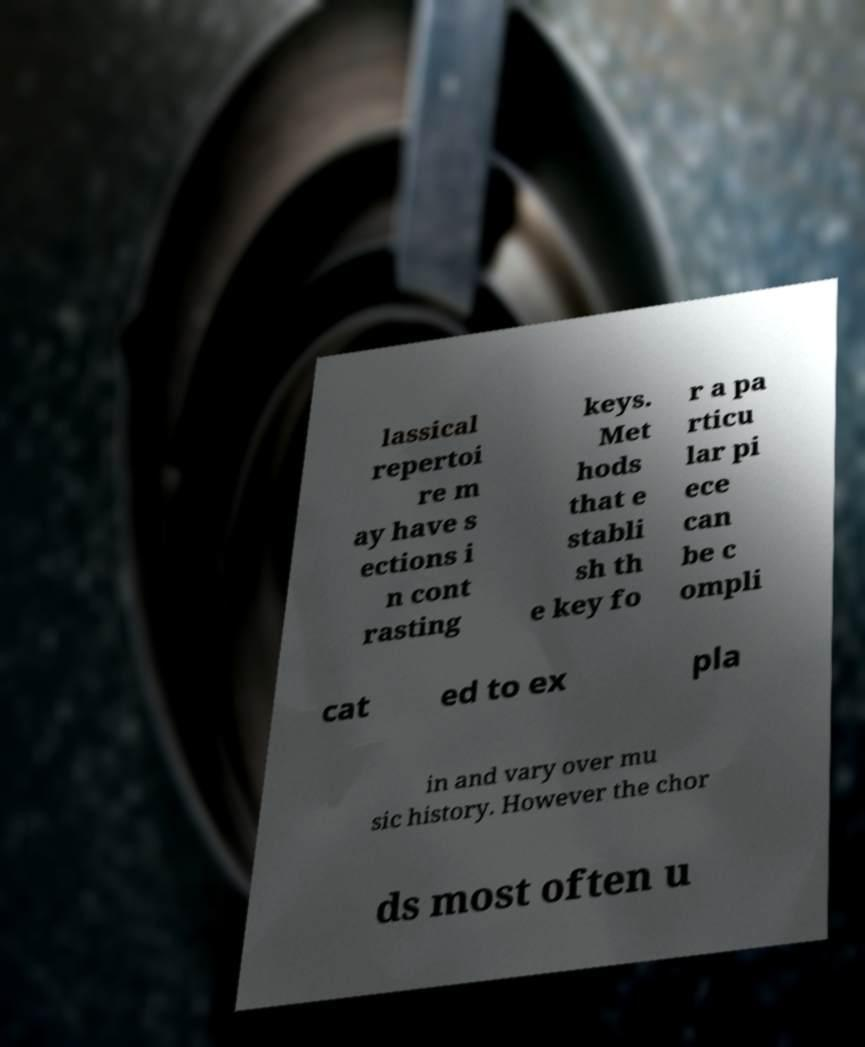Please identify and transcribe the text found in this image. lassical repertoi re m ay have s ections i n cont rasting keys. Met hods that e stabli sh th e key fo r a pa rticu lar pi ece can be c ompli cat ed to ex pla in and vary over mu sic history. However the chor ds most often u 